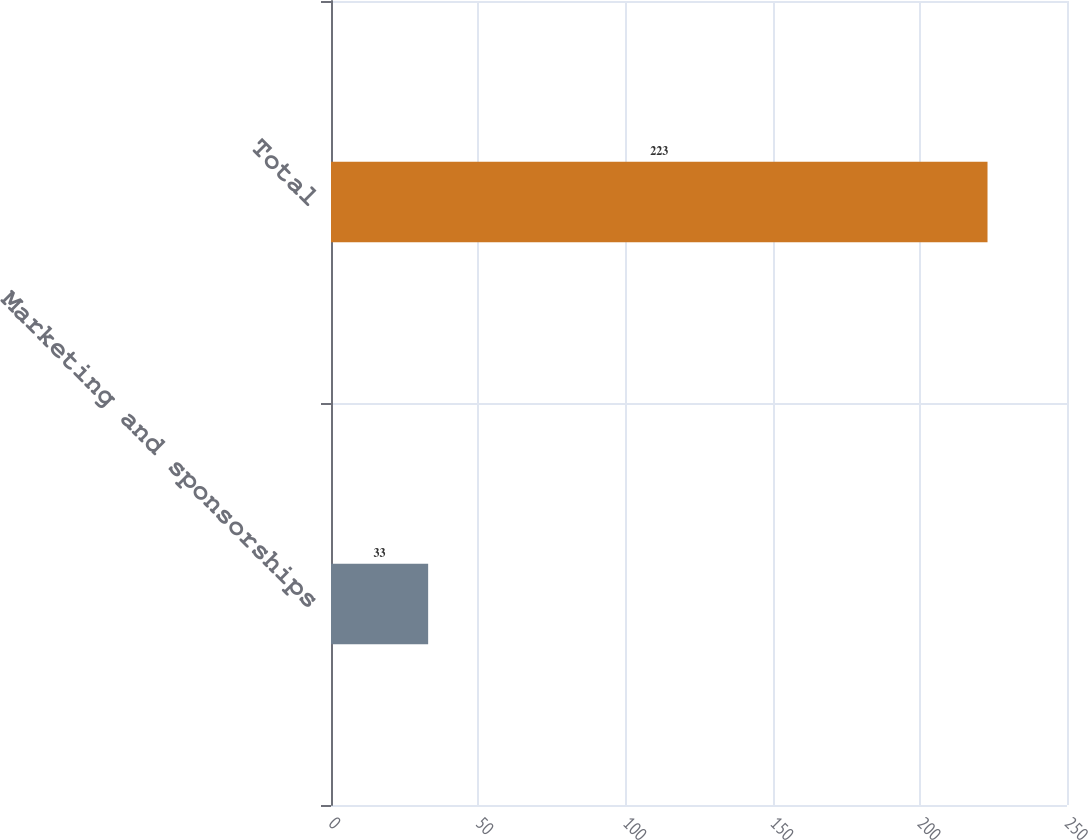Convert chart. <chart><loc_0><loc_0><loc_500><loc_500><bar_chart><fcel>Marketing and sponsorships<fcel>Total<nl><fcel>33<fcel>223<nl></chart> 